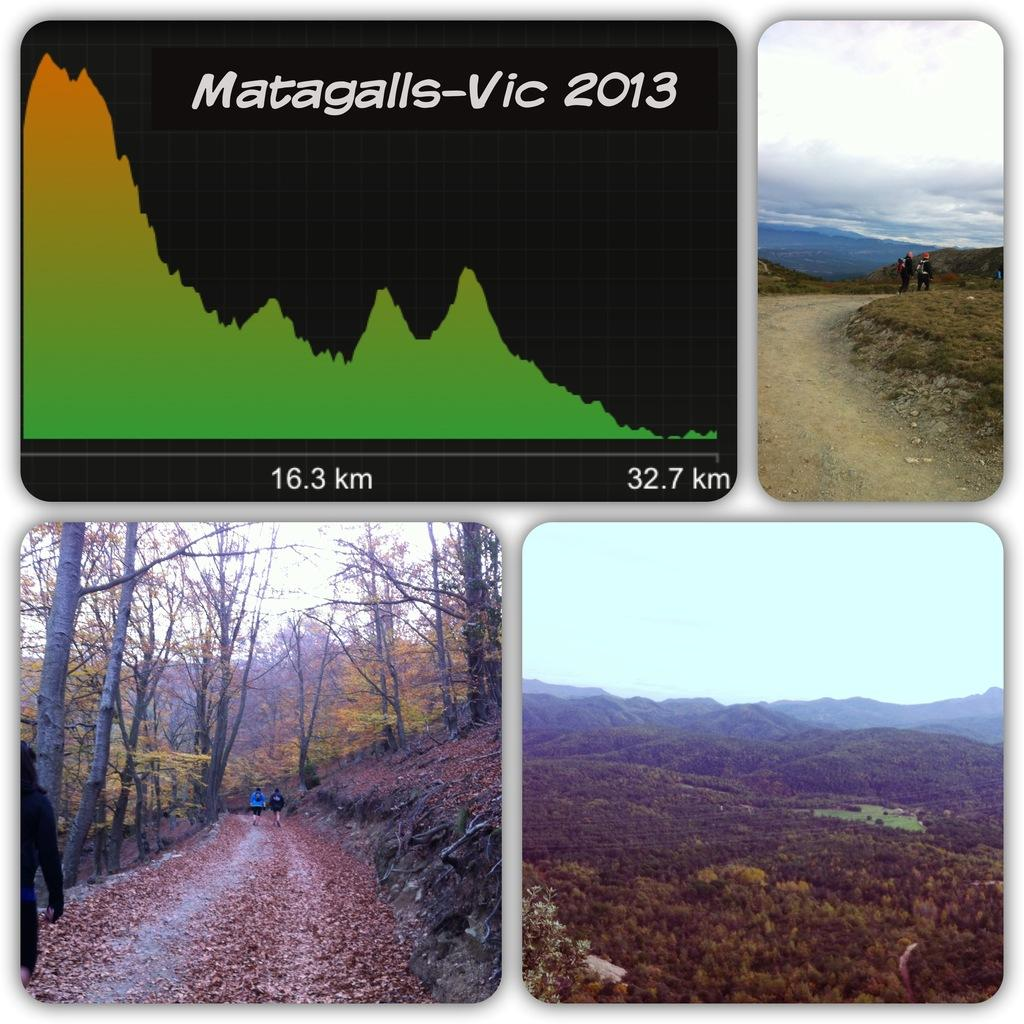What type of image is shown in the collage? The image is a collage of scenery images. How many images are included in the collage? There are four images in the collage. Can you describe the content of the images? In two of the images, there are people walking. How many boys are playing with the hose in the yard in the image? There is no image of boys playing with a hose in the yard in the collage. 